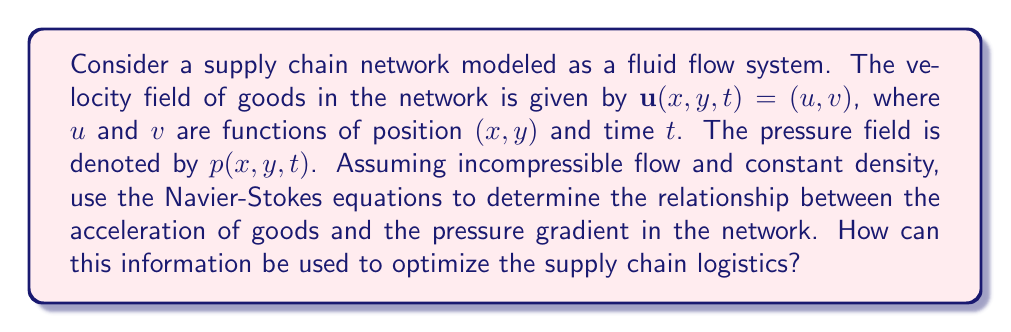Show me your answer to this math problem. To solve this problem, we'll use the Navier-Stokes equations for incompressible flow with constant density. The equations are:

1. Continuity equation:
   $$\nabla \cdot \mathbf{u} = 0$$

2. Momentum equation:
   $$\rho \left(\frac{\partial \mathbf{u}}{\partial t} + (\mathbf{u} \cdot \nabla)\mathbf{u}\right) = -\nabla p + \mu \nabla^2 \mathbf{u} + \mathbf{f}$$

Where:
- $\rho$ is the density (constant in this case)
- $\mu$ is the dynamic viscosity
- $\mathbf{f}$ represents external forces

For our supply chain network:

1. The continuity equation implies that the flow of goods is conserved throughout the network.

2. The momentum equation describes the relationship between acceleration, pressure gradient, and other forces.

Let's focus on the left-hand side of the momentum equation:

$$\rho \left(\frac{\partial \mathbf{u}}{\partial t} + (\mathbf{u} \cdot \nabla)\mathbf{u}\right)$$

This represents the acceleration of goods in the network. It consists of two terms:
- $\frac{\partial \mathbf{u}}{\partial t}$: the local acceleration (rate of change at a fixed point)
- $(\mathbf{u} \cdot \nabla)\mathbf{u}$: the convective acceleration (change due to movement through the network)

On the right-hand side, we have:

$$-\nabla p + \mu \nabla^2 \mathbf{u} + \mathbf{f}$$

The term $-\nabla p$ represents the pressure gradient in the network. This drives the flow of goods from high-pressure (high inventory) areas to low-pressure (low inventory) areas.

To optimize the supply chain logistics:

1. Analyze the pressure gradient $-\nabla p$ to identify bottlenecks and areas of congestion in the network.
2. Use the viscosity term $\mu \nabla^2 \mathbf{u}$ to model the resistance to flow in different parts of the network.
3. Incorporate external forces $\mathbf{f}$ to represent factors like demand fluctuations or supply disruptions.
4. Balance the acceleration terms with the pressure gradient and other forces to achieve optimal flow.

By understanding these relationships, supply chain managers can:
- Adjust inventory levels to reduce pressure gradients
- Improve infrastructure to reduce viscosity (resistance to flow)
- Implement predictive models to anticipate and respond to external forces
- Optimize routing and scheduling to minimize acceleration and deceleration of goods
Answer: The Navier-Stokes equations reveal that the acceleration of goods in the supply chain network is balanced by the pressure gradient, viscous forces, and external factors. Optimizing supply chain logistics involves:
1. Minimizing pressure gradients to reduce congestion
2. Reducing network viscosity to improve flow
3. Anticipating and responding to external forces
4. Balancing acceleration and deceleration of goods for efficient movement

By applying these principles, supply chain managers can use data-driven approaches to optimize inventory levels, improve infrastructure, implement predictive models, and enhance routing and scheduling strategies. 